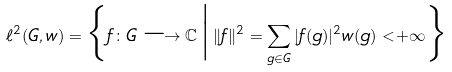Convert formula to latex. <formula><loc_0><loc_0><loc_500><loc_500>\ell ^ { 2 } ( G , w ) = \Big \{ f \colon G \longrightarrow \mathbb { C } \, \Big | \, \| f \| ^ { 2 } = \sum _ { g \in G } | f ( g ) | ^ { 2 } w ( g ) < + \infty \Big \}</formula> 